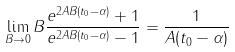Convert formula to latex. <formula><loc_0><loc_0><loc_500><loc_500>\lim _ { B \rightarrow 0 } B \frac { e ^ { 2 A B ( t _ { 0 } - \alpha ) } + 1 } { e ^ { 2 A B ( t _ { 0 } - \alpha ) } - 1 } = \frac { 1 } { A ( t _ { 0 } - \alpha ) }</formula> 